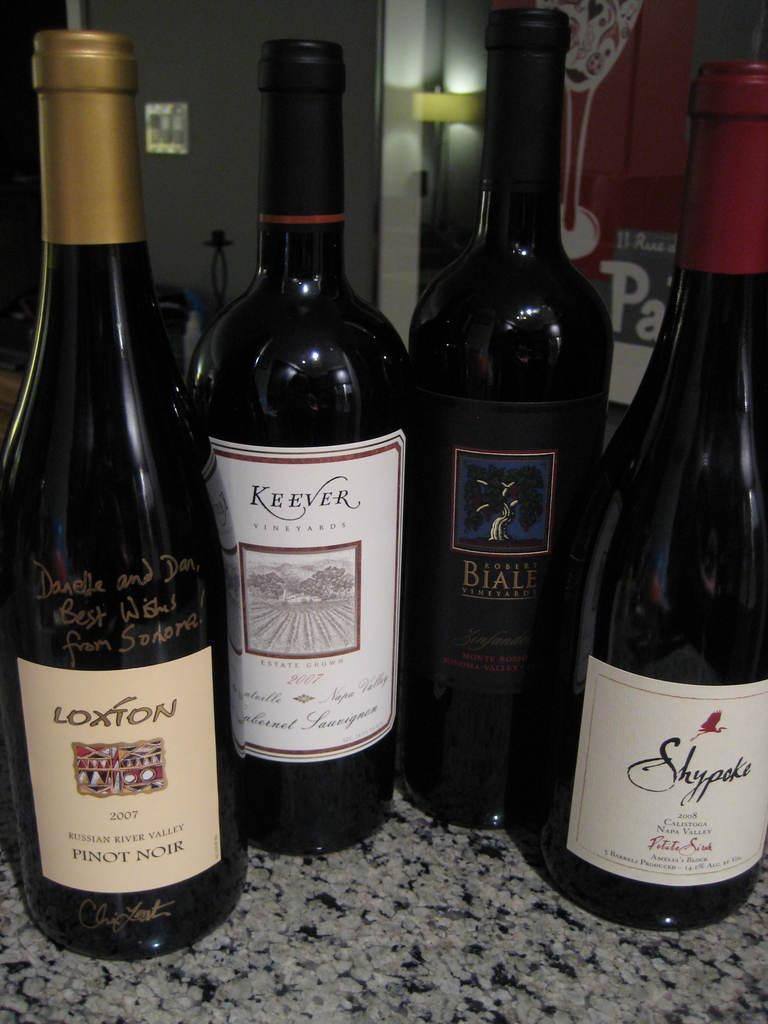How many bottles are visible in the image? There are four bottles in the image. What is on the bottles? Stickers are pasted on the bottles. What can be seen in the background of the image? There is a wall and a door in the background of the image. What information is provided on the stickers? There is text on the stickers. What color is the eggnog in the image? There is no eggnog present in the image; it only shows bottles with stickers on them. Can you tell me how many eyes are visible on the bottles? There are no eyes visible on the bottles in the image. 